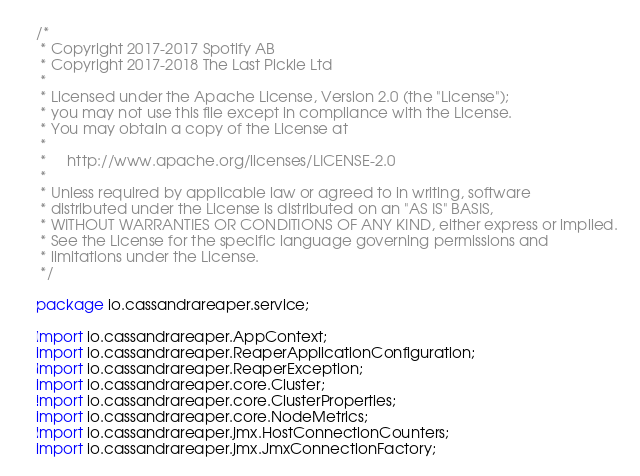<code> <loc_0><loc_0><loc_500><loc_500><_Java_>/*
 * Copyright 2017-2017 Spotify AB
 * Copyright 2017-2018 The Last Pickle Ltd
 *
 * Licensed under the Apache License, Version 2.0 (the "License");
 * you may not use this file except in compliance with the License.
 * You may obtain a copy of the License at
 *
 *     http://www.apache.org/licenses/LICENSE-2.0
 *
 * Unless required by applicable law or agreed to in writing, software
 * distributed under the License is distributed on an "AS IS" BASIS,
 * WITHOUT WARRANTIES OR CONDITIONS OF ANY KIND, either express or implied.
 * See the License for the specific language governing permissions and
 * limitations under the License.
 */

package io.cassandrareaper.service;

import io.cassandrareaper.AppContext;
import io.cassandrareaper.ReaperApplicationConfiguration;
import io.cassandrareaper.ReaperException;
import io.cassandrareaper.core.Cluster;
import io.cassandrareaper.core.ClusterProperties;
import io.cassandrareaper.core.NodeMetrics;
import io.cassandrareaper.jmx.HostConnectionCounters;
import io.cassandrareaper.jmx.JmxConnectionFactory;</code> 